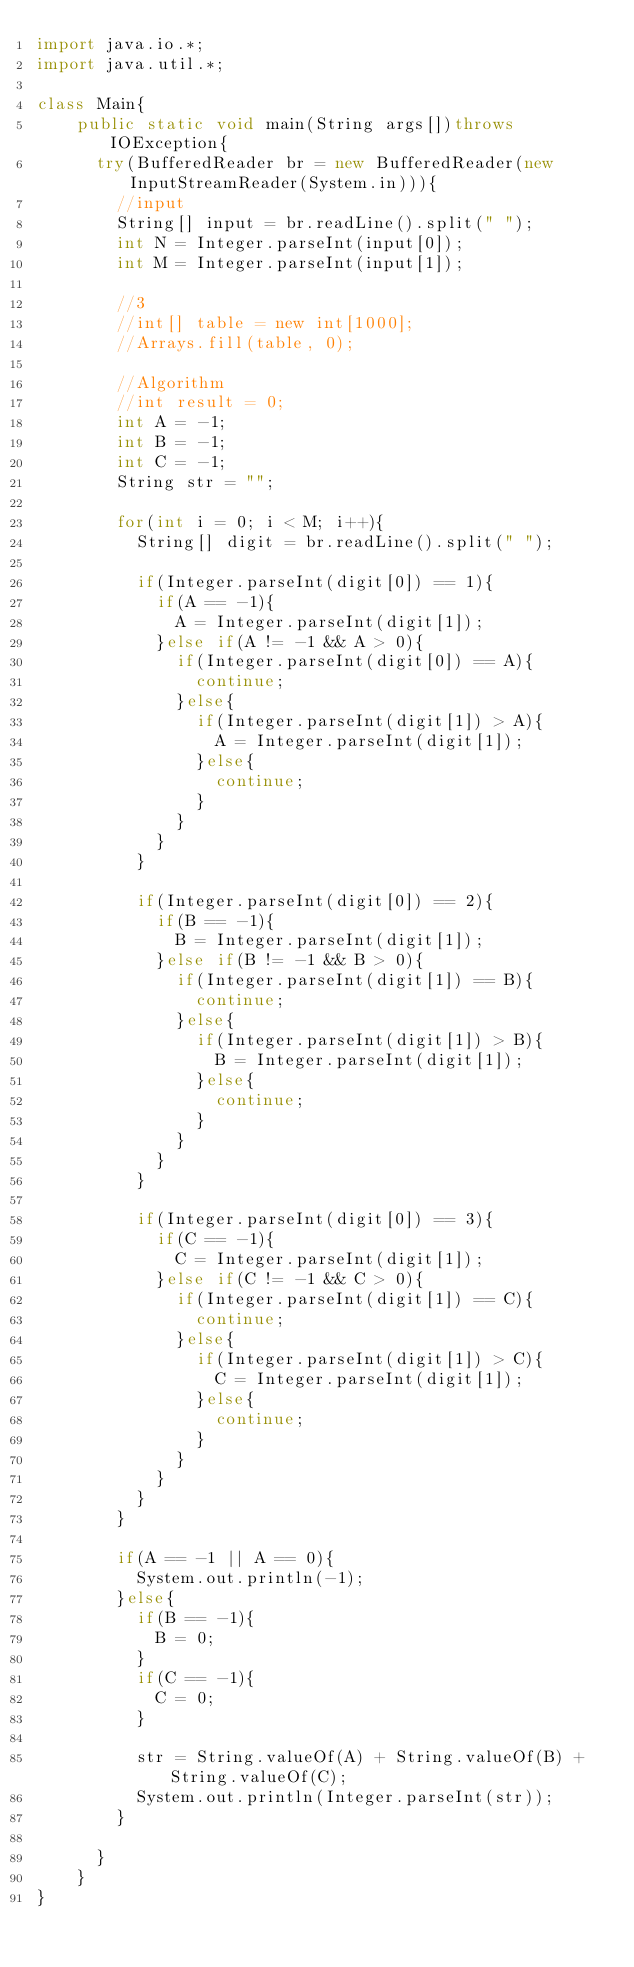Convert code to text. <code><loc_0><loc_0><loc_500><loc_500><_Java_>import java.io.*;
import java.util.*;

class Main{
    public static void main(String args[])throws IOException{
      try(BufferedReader br = new BufferedReader(new InputStreamReader(System.in))){
        //input
        String[] input = br.readLine().split(" ");
        int N = Integer.parseInt(input[0]);
        int M = Integer.parseInt(input[1]);

        //3
        //int[] table = new int[1000];
        //Arrays.fill(table, 0);

        //Algorithm
        //int result = 0;
        int A = -1;
        int B = -1;
        int C = -1;
        String str = "";

        for(int i = 0; i < M; i++){
          String[] digit = br.readLine().split(" ");

          if(Integer.parseInt(digit[0]) == 1){
            if(A == -1){
              A = Integer.parseInt(digit[1]);
            }else if(A != -1 && A > 0){
              if(Integer.parseInt(digit[0]) == A){
                continue;
              }else{
                if(Integer.parseInt(digit[1]) > A){
                  A = Integer.parseInt(digit[1]);
                }else{
                  continue;
                }
              }
            }
          }
            
          if(Integer.parseInt(digit[0]) == 2){
            if(B == -1){
              B = Integer.parseInt(digit[1]);
            }else if(B != -1 && B > 0){
              if(Integer.parseInt(digit[1]) == B){
                continue;
              }else{
                if(Integer.parseInt(digit[1]) > B){
                  B = Integer.parseInt(digit[1]);
                }else{
                  continue;
                }
              }
            }
          }

          if(Integer.parseInt(digit[0]) == 3){
            if(C == -1){
              C = Integer.parseInt(digit[1]);
            }else if(C != -1 && C > 0){
              if(Integer.parseInt(digit[1]) == C){
                continue;
              }else{
                if(Integer.parseInt(digit[1]) > C){
                  C = Integer.parseInt(digit[1]);
                }else{
                  continue;
                }
              }
            }
          }
        }

        if(A == -1 || A == 0){
          System.out.println(-1);
        }else{
          if(B == -1){
            B = 0;
          }
          if(C == -1){
            C = 0;
          }

          str = String.valueOf(A) + String.valueOf(B) + String.valueOf(C);
          System.out.println(Integer.parseInt(str));
        }

      }
    }
}</code> 